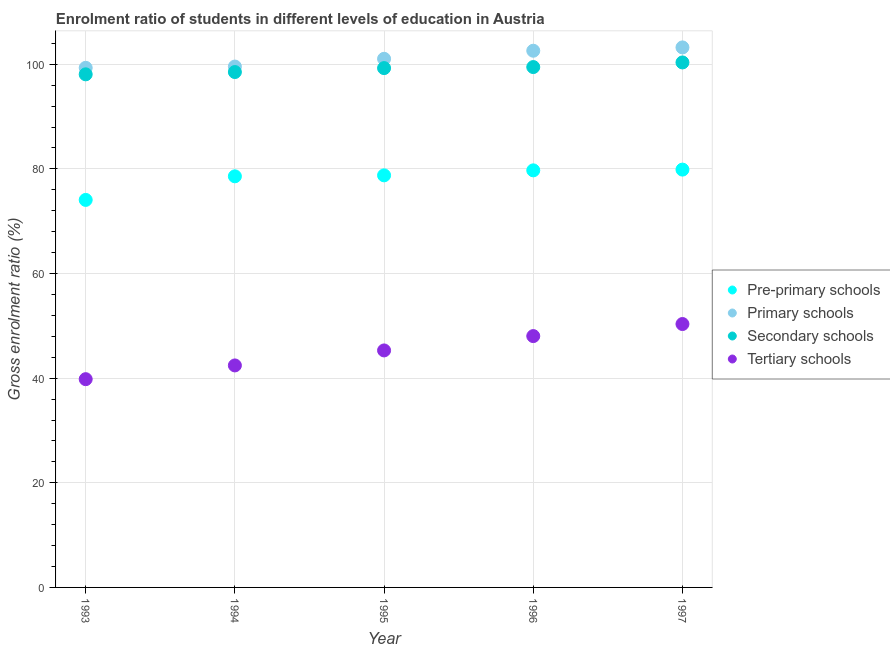Is the number of dotlines equal to the number of legend labels?
Your answer should be very brief. Yes. What is the gross enrolment ratio in primary schools in 1996?
Your answer should be very brief. 102.59. Across all years, what is the maximum gross enrolment ratio in pre-primary schools?
Offer a very short reply. 79.87. Across all years, what is the minimum gross enrolment ratio in primary schools?
Offer a terse response. 99.32. In which year was the gross enrolment ratio in primary schools maximum?
Your answer should be compact. 1997. In which year was the gross enrolment ratio in primary schools minimum?
Keep it short and to the point. 1993. What is the total gross enrolment ratio in tertiary schools in the graph?
Make the answer very short. 225.94. What is the difference between the gross enrolment ratio in pre-primary schools in 1994 and that in 1997?
Give a very brief answer. -1.28. What is the difference between the gross enrolment ratio in primary schools in 1993 and the gross enrolment ratio in pre-primary schools in 1996?
Keep it short and to the point. 19.6. What is the average gross enrolment ratio in pre-primary schools per year?
Your response must be concise. 78.2. In the year 1995, what is the difference between the gross enrolment ratio in pre-primary schools and gross enrolment ratio in tertiary schools?
Keep it short and to the point. 33.47. In how many years, is the gross enrolment ratio in secondary schools greater than 80 %?
Ensure brevity in your answer.  5. What is the ratio of the gross enrolment ratio in tertiary schools in 1993 to that in 1994?
Give a very brief answer. 0.94. What is the difference between the highest and the second highest gross enrolment ratio in primary schools?
Give a very brief answer. 0.63. What is the difference between the highest and the lowest gross enrolment ratio in secondary schools?
Your response must be concise. 2.27. In how many years, is the gross enrolment ratio in primary schools greater than the average gross enrolment ratio in primary schools taken over all years?
Your answer should be very brief. 2. Is it the case that in every year, the sum of the gross enrolment ratio in pre-primary schools and gross enrolment ratio in secondary schools is greater than the sum of gross enrolment ratio in tertiary schools and gross enrolment ratio in primary schools?
Your answer should be compact. Yes. Is it the case that in every year, the sum of the gross enrolment ratio in pre-primary schools and gross enrolment ratio in primary schools is greater than the gross enrolment ratio in secondary schools?
Offer a terse response. Yes. Does the gross enrolment ratio in tertiary schools monotonically increase over the years?
Provide a short and direct response. Yes. Is the gross enrolment ratio in secondary schools strictly less than the gross enrolment ratio in tertiary schools over the years?
Your answer should be very brief. No. Does the graph contain any zero values?
Give a very brief answer. No. What is the title of the graph?
Your response must be concise. Enrolment ratio of students in different levels of education in Austria. What is the label or title of the X-axis?
Provide a short and direct response. Year. What is the label or title of the Y-axis?
Your response must be concise. Gross enrolment ratio (%). What is the Gross enrolment ratio (%) in Pre-primary schools in 1993?
Your answer should be very brief. 74.07. What is the Gross enrolment ratio (%) of Primary schools in 1993?
Ensure brevity in your answer.  99.32. What is the Gross enrolment ratio (%) in Secondary schools in 1993?
Ensure brevity in your answer.  98.08. What is the Gross enrolment ratio (%) of Tertiary schools in 1993?
Keep it short and to the point. 39.81. What is the Gross enrolment ratio (%) of Pre-primary schools in 1994?
Keep it short and to the point. 78.59. What is the Gross enrolment ratio (%) in Primary schools in 1994?
Offer a terse response. 99.57. What is the Gross enrolment ratio (%) of Secondary schools in 1994?
Provide a short and direct response. 98.52. What is the Gross enrolment ratio (%) of Tertiary schools in 1994?
Provide a succinct answer. 42.43. What is the Gross enrolment ratio (%) of Pre-primary schools in 1995?
Keep it short and to the point. 78.77. What is the Gross enrolment ratio (%) of Primary schools in 1995?
Your answer should be compact. 101.05. What is the Gross enrolment ratio (%) of Secondary schools in 1995?
Your answer should be compact. 99.27. What is the Gross enrolment ratio (%) in Tertiary schools in 1995?
Your answer should be compact. 45.3. What is the Gross enrolment ratio (%) in Pre-primary schools in 1996?
Provide a short and direct response. 79.72. What is the Gross enrolment ratio (%) of Primary schools in 1996?
Your answer should be very brief. 102.59. What is the Gross enrolment ratio (%) of Secondary schools in 1996?
Offer a very short reply. 99.47. What is the Gross enrolment ratio (%) of Tertiary schools in 1996?
Ensure brevity in your answer.  48.04. What is the Gross enrolment ratio (%) of Pre-primary schools in 1997?
Your answer should be very brief. 79.87. What is the Gross enrolment ratio (%) of Primary schools in 1997?
Keep it short and to the point. 103.22. What is the Gross enrolment ratio (%) of Secondary schools in 1997?
Make the answer very short. 100.35. What is the Gross enrolment ratio (%) of Tertiary schools in 1997?
Offer a terse response. 50.35. Across all years, what is the maximum Gross enrolment ratio (%) in Pre-primary schools?
Your response must be concise. 79.87. Across all years, what is the maximum Gross enrolment ratio (%) of Primary schools?
Your response must be concise. 103.22. Across all years, what is the maximum Gross enrolment ratio (%) of Secondary schools?
Offer a very short reply. 100.35. Across all years, what is the maximum Gross enrolment ratio (%) in Tertiary schools?
Ensure brevity in your answer.  50.35. Across all years, what is the minimum Gross enrolment ratio (%) of Pre-primary schools?
Offer a very short reply. 74.07. Across all years, what is the minimum Gross enrolment ratio (%) of Primary schools?
Make the answer very short. 99.32. Across all years, what is the minimum Gross enrolment ratio (%) in Secondary schools?
Offer a terse response. 98.08. Across all years, what is the minimum Gross enrolment ratio (%) in Tertiary schools?
Give a very brief answer. 39.81. What is the total Gross enrolment ratio (%) of Pre-primary schools in the graph?
Provide a succinct answer. 391.02. What is the total Gross enrolment ratio (%) in Primary schools in the graph?
Give a very brief answer. 505.75. What is the total Gross enrolment ratio (%) in Secondary schools in the graph?
Provide a succinct answer. 495.68. What is the total Gross enrolment ratio (%) of Tertiary schools in the graph?
Provide a succinct answer. 225.94. What is the difference between the Gross enrolment ratio (%) in Pre-primary schools in 1993 and that in 1994?
Give a very brief answer. -4.51. What is the difference between the Gross enrolment ratio (%) in Primary schools in 1993 and that in 1994?
Offer a terse response. -0.24. What is the difference between the Gross enrolment ratio (%) of Secondary schools in 1993 and that in 1994?
Keep it short and to the point. -0.44. What is the difference between the Gross enrolment ratio (%) in Tertiary schools in 1993 and that in 1994?
Give a very brief answer. -2.63. What is the difference between the Gross enrolment ratio (%) in Pre-primary schools in 1993 and that in 1995?
Make the answer very short. -4.69. What is the difference between the Gross enrolment ratio (%) of Primary schools in 1993 and that in 1995?
Provide a succinct answer. -1.72. What is the difference between the Gross enrolment ratio (%) of Secondary schools in 1993 and that in 1995?
Provide a short and direct response. -1.19. What is the difference between the Gross enrolment ratio (%) in Tertiary schools in 1993 and that in 1995?
Provide a succinct answer. -5.49. What is the difference between the Gross enrolment ratio (%) of Pre-primary schools in 1993 and that in 1996?
Your response must be concise. -5.65. What is the difference between the Gross enrolment ratio (%) of Primary schools in 1993 and that in 1996?
Offer a very short reply. -3.27. What is the difference between the Gross enrolment ratio (%) of Secondary schools in 1993 and that in 1996?
Your answer should be very brief. -1.39. What is the difference between the Gross enrolment ratio (%) of Tertiary schools in 1993 and that in 1996?
Provide a short and direct response. -8.23. What is the difference between the Gross enrolment ratio (%) of Pre-primary schools in 1993 and that in 1997?
Provide a succinct answer. -5.79. What is the difference between the Gross enrolment ratio (%) in Primary schools in 1993 and that in 1997?
Make the answer very short. -3.9. What is the difference between the Gross enrolment ratio (%) in Secondary schools in 1993 and that in 1997?
Provide a short and direct response. -2.27. What is the difference between the Gross enrolment ratio (%) of Tertiary schools in 1993 and that in 1997?
Make the answer very short. -10.54. What is the difference between the Gross enrolment ratio (%) in Pre-primary schools in 1994 and that in 1995?
Give a very brief answer. -0.18. What is the difference between the Gross enrolment ratio (%) in Primary schools in 1994 and that in 1995?
Your response must be concise. -1.48. What is the difference between the Gross enrolment ratio (%) of Secondary schools in 1994 and that in 1995?
Give a very brief answer. -0.75. What is the difference between the Gross enrolment ratio (%) in Tertiary schools in 1994 and that in 1995?
Provide a succinct answer. -2.87. What is the difference between the Gross enrolment ratio (%) in Pre-primary schools in 1994 and that in 1996?
Keep it short and to the point. -1.14. What is the difference between the Gross enrolment ratio (%) in Primary schools in 1994 and that in 1996?
Make the answer very short. -3.02. What is the difference between the Gross enrolment ratio (%) of Secondary schools in 1994 and that in 1996?
Your answer should be very brief. -0.95. What is the difference between the Gross enrolment ratio (%) of Tertiary schools in 1994 and that in 1996?
Give a very brief answer. -5.61. What is the difference between the Gross enrolment ratio (%) in Pre-primary schools in 1994 and that in 1997?
Your answer should be very brief. -1.28. What is the difference between the Gross enrolment ratio (%) of Primary schools in 1994 and that in 1997?
Ensure brevity in your answer.  -3.66. What is the difference between the Gross enrolment ratio (%) in Secondary schools in 1994 and that in 1997?
Your answer should be very brief. -1.84. What is the difference between the Gross enrolment ratio (%) of Tertiary schools in 1994 and that in 1997?
Your answer should be compact. -7.91. What is the difference between the Gross enrolment ratio (%) of Pre-primary schools in 1995 and that in 1996?
Offer a terse response. -0.95. What is the difference between the Gross enrolment ratio (%) of Primary schools in 1995 and that in 1996?
Provide a succinct answer. -1.54. What is the difference between the Gross enrolment ratio (%) in Secondary schools in 1995 and that in 1996?
Provide a short and direct response. -0.2. What is the difference between the Gross enrolment ratio (%) in Tertiary schools in 1995 and that in 1996?
Your answer should be compact. -2.74. What is the difference between the Gross enrolment ratio (%) of Pre-primary schools in 1995 and that in 1997?
Your response must be concise. -1.1. What is the difference between the Gross enrolment ratio (%) of Primary schools in 1995 and that in 1997?
Your answer should be compact. -2.18. What is the difference between the Gross enrolment ratio (%) of Secondary schools in 1995 and that in 1997?
Keep it short and to the point. -1.08. What is the difference between the Gross enrolment ratio (%) in Tertiary schools in 1995 and that in 1997?
Your response must be concise. -5.05. What is the difference between the Gross enrolment ratio (%) of Pre-primary schools in 1996 and that in 1997?
Make the answer very short. -0.14. What is the difference between the Gross enrolment ratio (%) in Primary schools in 1996 and that in 1997?
Make the answer very short. -0.63. What is the difference between the Gross enrolment ratio (%) of Secondary schools in 1996 and that in 1997?
Make the answer very short. -0.88. What is the difference between the Gross enrolment ratio (%) in Tertiary schools in 1996 and that in 1997?
Offer a very short reply. -2.31. What is the difference between the Gross enrolment ratio (%) of Pre-primary schools in 1993 and the Gross enrolment ratio (%) of Primary schools in 1994?
Your response must be concise. -25.49. What is the difference between the Gross enrolment ratio (%) of Pre-primary schools in 1993 and the Gross enrolment ratio (%) of Secondary schools in 1994?
Offer a very short reply. -24.44. What is the difference between the Gross enrolment ratio (%) in Pre-primary schools in 1993 and the Gross enrolment ratio (%) in Tertiary schools in 1994?
Ensure brevity in your answer.  31.64. What is the difference between the Gross enrolment ratio (%) in Primary schools in 1993 and the Gross enrolment ratio (%) in Secondary schools in 1994?
Make the answer very short. 0.81. What is the difference between the Gross enrolment ratio (%) in Primary schools in 1993 and the Gross enrolment ratio (%) in Tertiary schools in 1994?
Provide a succinct answer. 56.89. What is the difference between the Gross enrolment ratio (%) in Secondary schools in 1993 and the Gross enrolment ratio (%) in Tertiary schools in 1994?
Make the answer very short. 55.64. What is the difference between the Gross enrolment ratio (%) in Pre-primary schools in 1993 and the Gross enrolment ratio (%) in Primary schools in 1995?
Make the answer very short. -26.97. What is the difference between the Gross enrolment ratio (%) of Pre-primary schools in 1993 and the Gross enrolment ratio (%) of Secondary schools in 1995?
Provide a short and direct response. -25.19. What is the difference between the Gross enrolment ratio (%) of Pre-primary schools in 1993 and the Gross enrolment ratio (%) of Tertiary schools in 1995?
Ensure brevity in your answer.  28.77. What is the difference between the Gross enrolment ratio (%) in Primary schools in 1993 and the Gross enrolment ratio (%) in Secondary schools in 1995?
Provide a short and direct response. 0.05. What is the difference between the Gross enrolment ratio (%) of Primary schools in 1993 and the Gross enrolment ratio (%) of Tertiary schools in 1995?
Provide a short and direct response. 54.02. What is the difference between the Gross enrolment ratio (%) of Secondary schools in 1993 and the Gross enrolment ratio (%) of Tertiary schools in 1995?
Keep it short and to the point. 52.78. What is the difference between the Gross enrolment ratio (%) of Pre-primary schools in 1993 and the Gross enrolment ratio (%) of Primary schools in 1996?
Keep it short and to the point. -28.52. What is the difference between the Gross enrolment ratio (%) in Pre-primary schools in 1993 and the Gross enrolment ratio (%) in Secondary schools in 1996?
Provide a succinct answer. -25.39. What is the difference between the Gross enrolment ratio (%) of Pre-primary schools in 1993 and the Gross enrolment ratio (%) of Tertiary schools in 1996?
Give a very brief answer. 26.03. What is the difference between the Gross enrolment ratio (%) of Primary schools in 1993 and the Gross enrolment ratio (%) of Secondary schools in 1996?
Provide a succinct answer. -0.15. What is the difference between the Gross enrolment ratio (%) in Primary schools in 1993 and the Gross enrolment ratio (%) in Tertiary schools in 1996?
Give a very brief answer. 51.28. What is the difference between the Gross enrolment ratio (%) in Secondary schools in 1993 and the Gross enrolment ratio (%) in Tertiary schools in 1996?
Ensure brevity in your answer.  50.04. What is the difference between the Gross enrolment ratio (%) in Pre-primary schools in 1993 and the Gross enrolment ratio (%) in Primary schools in 1997?
Provide a short and direct response. -29.15. What is the difference between the Gross enrolment ratio (%) in Pre-primary schools in 1993 and the Gross enrolment ratio (%) in Secondary schools in 1997?
Ensure brevity in your answer.  -26.28. What is the difference between the Gross enrolment ratio (%) in Pre-primary schools in 1993 and the Gross enrolment ratio (%) in Tertiary schools in 1997?
Offer a terse response. 23.72. What is the difference between the Gross enrolment ratio (%) in Primary schools in 1993 and the Gross enrolment ratio (%) in Secondary schools in 1997?
Your answer should be compact. -1.03. What is the difference between the Gross enrolment ratio (%) in Primary schools in 1993 and the Gross enrolment ratio (%) in Tertiary schools in 1997?
Offer a terse response. 48.97. What is the difference between the Gross enrolment ratio (%) in Secondary schools in 1993 and the Gross enrolment ratio (%) in Tertiary schools in 1997?
Provide a succinct answer. 47.73. What is the difference between the Gross enrolment ratio (%) of Pre-primary schools in 1994 and the Gross enrolment ratio (%) of Primary schools in 1995?
Make the answer very short. -22.46. What is the difference between the Gross enrolment ratio (%) in Pre-primary schools in 1994 and the Gross enrolment ratio (%) in Secondary schools in 1995?
Your answer should be very brief. -20.68. What is the difference between the Gross enrolment ratio (%) of Pre-primary schools in 1994 and the Gross enrolment ratio (%) of Tertiary schools in 1995?
Your answer should be compact. 33.28. What is the difference between the Gross enrolment ratio (%) in Primary schools in 1994 and the Gross enrolment ratio (%) in Secondary schools in 1995?
Offer a very short reply. 0.3. What is the difference between the Gross enrolment ratio (%) of Primary schools in 1994 and the Gross enrolment ratio (%) of Tertiary schools in 1995?
Provide a short and direct response. 54.26. What is the difference between the Gross enrolment ratio (%) in Secondary schools in 1994 and the Gross enrolment ratio (%) in Tertiary schools in 1995?
Your answer should be very brief. 53.21. What is the difference between the Gross enrolment ratio (%) in Pre-primary schools in 1994 and the Gross enrolment ratio (%) in Primary schools in 1996?
Make the answer very short. -24. What is the difference between the Gross enrolment ratio (%) in Pre-primary schools in 1994 and the Gross enrolment ratio (%) in Secondary schools in 1996?
Make the answer very short. -20.88. What is the difference between the Gross enrolment ratio (%) in Pre-primary schools in 1994 and the Gross enrolment ratio (%) in Tertiary schools in 1996?
Provide a succinct answer. 30.54. What is the difference between the Gross enrolment ratio (%) of Primary schools in 1994 and the Gross enrolment ratio (%) of Secondary schools in 1996?
Your answer should be very brief. 0.1. What is the difference between the Gross enrolment ratio (%) in Primary schools in 1994 and the Gross enrolment ratio (%) in Tertiary schools in 1996?
Offer a terse response. 51.52. What is the difference between the Gross enrolment ratio (%) in Secondary schools in 1994 and the Gross enrolment ratio (%) in Tertiary schools in 1996?
Your answer should be compact. 50.47. What is the difference between the Gross enrolment ratio (%) in Pre-primary schools in 1994 and the Gross enrolment ratio (%) in Primary schools in 1997?
Ensure brevity in your answer.  -24.64. What is the difference between the Gross enrolment ratio (%) in Pre-primary schools in 1994 and the Gross enrolment ratio (%) in Secondary schools in 1997?
Your response must be concise. -21.77. What is the difference between the Gross enrolment ratio (%) of Pre-primary schools in 1994 and the Gross enrolment ratio (%) of Tertiary schools in 1997?
Offer a terse response. 28.24. What is the difference between the Gross enrolment ratio (%) of Primary schools in 1994 and the Gross enrolment ratio (%) of Secondary schools in 1997?
Keep it short and to the point. -0.79. What is the difference between the Gross enrolment ratio (%) in Primary schools in 1994 and the Gross enrolment ratio (%) in Tertiary schools in 1997?
Make the answer very short. 49.22. What is the difference between the Gross enrolment ratio (%) of Secondary schools in 1994 and the Gross enrolment ratio (%) of Tertiary schools in 1997?
Keep it short and to the point. 48.17. What is the difference between the Gross enrolment ratio (%) in Pre-primary schools in 1995 and the Gross enrolment ratio (%) in Primary schools in 1996?
Your answer should be compact. -23.82. What is the difference between the Gross enrolment ratio (%) in Pre-primary schools in 1995 and the Gross enrolment ratio (%) in Secondary schools in 1996?
Offer a very short reply. -20.7. What is the difference between the Gross enrolment ratio (%) of Pre-primary schools in 1995 and the Gross enrolment ratio (%) of Tertiary schools in 1996?
Give a very brief answer. 30.73. What is the difference between the Gross enrolment ratio (%) of Primary schools in 1995 and the Gross enrolment ratio (%) of Secondary schools in 1996?
Give a very brief answer. 1.58. What is the difference between the Gross enrolment ratio (%) of Primary schools in 1995 and the Gross enrolment ratio (%) of Tertiary schools in 1996?
Provide a succinct answer. 53. What is the difference between the Gross enrolment ratio (%) of Secondary schools in 1995 and the Gross enrolment ratio (%) of Tertiary schools in 1996?
Provide a short and direct response. 51.23. What is the difference between the Gross enrolment ratio (%) in Pre-primary schools in 1995 and the Gross enrolment ratio (%) in Primary schools in 1997?
Provide a short and direct response. -24.46. What is the difference between the Gross enrolment ratio (%) in Pre-primary schools in 1995 and the Gross enrolment ratio (%) in Secondary schools in 1997?
Give a very brief answer. -21.58. What is the difference between the Gross enrolment ratio (%) of Pre-primary schools in 1995 and the Gross enrolment ratio (%) of Tertiary schools in 1997?
Keep it short and to the point. 28.42. What is the difference between the Gross enrolment ratio (%) in Primary schools in 1995 and the Gross enrolment ratio (%) in Secondary schools in 1997?
Your answer should be compact. 0.69. What is the difference between the Gross enrolment ratio (%) of Primary schools in 1995 and the Gross enrolment ratio (%) of Tertiary schools in 1997?
Your answer should be very brief. 50.7. What is the difference between the Gross enrolment ratio (%) in Secondary schools in 1995 and the Gross enrolment ratio (%) in Tertiary schools in 1997?
Give a very brief answer. 48.92. What is the difference between the Gross enrolment ratio (%) in Pre-primary schools in 1996 and the Gross enrolment ratio (%) in Primary schools in 1997?
Offer a terse response. -23.5. What is the difference between the Gross enrolment ratio (%) of Pre-primary schools in 1996 and the Gross enrolment ratio (%) of Secondary schools in 1997?
Your response must be concise. -20.63. What is the difference between the Gross enrolment ratio (%) in Pre-primary schools in 1996 and the Gross enrolment ratio (%) in Tertiary schools in 1997?
Your response must be concise. 29.37. What is the difference between the Gross enrolment ratio (%) of Primary schools in 1996 and the Gross enrolment ratio (%) of Secondary schools in 1997?
Your response must be concise. 2.24. What is the difference between the Gross enrolment ratio (%) of Primary schools in 1996 and the Gross enrolment ratio (%) of Tertiary schools in 1997?
Your answer should be compact. 52.24. What is the difference between the Gross enrolment ratio (%) in Secondary schools in 1996 and the Gross enrolment ratio (%) in Tertiary schools in 1997?
Provide a short and direct response. 49.12. What is the average Gross enrolment ratio (%) in Pre-primary schools per year?
Provide a short and direct response. 78.2. What is the average Gross enrolment ratio (%) in Primary schools per year?
Offer a terse response. 101.15. What is the average Gross enrolment ratio (%) of Secondary schools per year?
Ensure brevity in your answer.  99.14. What is the average Gross enrolment ratio (%) of Tertiary schools per year?
Provide a short and direct response. 45.19. In the year 1993, what is the difference between the Gross enrolment ratio (%) of Pre-primary schools and Gross enrolment ratio (%) of Primary schools?
Your response must be concise. -25.25. In the year 1993, what is the difference between the Gross enrolment ratio (%) in Pre-primary schools and Gross enrolment ratio (%) in Secondary schools?
Your answer should be compact. -24. In the year 1993, what is the difference between the Gross enrolment ratio (%) in Pre-primary schools and Gross enrolment ratio (%) in Tertiary schools?
Provide a short and direct response. 34.27. In the year 1993, what is the difference between the Gross enrolment ratio (%) in Primary schools and Gross enrolment ratio (%) in Secondary schools?
Provide a succinct answer. 1.24. In the year 1993, what is the difference between the Gross enrolment ratio (%) of Primary schools and Gross enrolment ratio (%) of Tertiary schools?
Give a very brief answer. 59.51. In the year 1993, what is the difference between the Gross enrolment ratio (%) in Secondary schools and Gross enrolment ratio (%) in Tertiary schools?
Keep it short and to the point. 58.27. In the year 1994, what is the difference between the Gross enrolment ratio (%) of Pre-primary schools and Gross enrolment ratio (%) of Primary schools?
Offer a very short reply. -20.98. In the year 1994, what is the difference between the Gross enrolment ratio (%) of Pre-primary schools and Gross enrolment ratio (%) of Secondary schools?
Your response must be concise. -19.93. In the year 1994, what is the difference between the Gross enrolment ratio (%) in Pre-primary schools and Gross enrolment ratio (%) in Tertiary schools?
Offer a terse response. 36.15. In the year 1994, what is the difference between the Gross enrolment ratio (%) in Primary schools and Gross enrolment ratio (%) in Secondary schools?
Make the answer very short. 1.05. In the year 1994, what is the difference between the Gross enrolment ratio (%) in Primary schools and Gross enrolment ratio (%) in Tertiary schools?
Provide a short and direct response. 57.13. In the year 1994, what is the difference between the Gross enrolment ratio (%) of Secondary schools and Gross enrolment ratio (%) of Tertiary schools?
Offer a terse response. 56.08. In the year 1995, what is the difference between the Gross enrolment ratio (%) in Pre-primary schools and Gross enrolment ratio (%) in Primary schools?
Keep it short and to the point. -22.28. In the year 1995, what is the difference between the Gross enrolment ratio (%) in Pre-primary schools and Gross enrolment ratio (%) in Secondary schools?
Offer a very short reply. -20.5. In the year 1995, what is the difference between the Gross enrolment ratio (%) of Pre-primary schools and Gross enrolment ratio (%) of Tertiary schools?
Keep it short and to the point. 33.47. In the year 1995, what is the difference between the Gross enrolment ratio (%) of Primary schools and Gross enrolment ratio (%) of Secondary schools?
Keep it short and to the point. 1.78. In the year 1995, what is the difference between the Gross enrolment ratio (%) in Primary schools and Gross enrolment ratio (%) in Tertiary schools?
Your answer should be very brief. 55.74. In the year 1995, what is the difference between the Gross enrolment ratio (%) of Secondary schools and Gross enrolment ratio (%) of Tertiary schools?
Your answer should be very brief. 53.97. In the year 1996, what is the difference between the Gross enrolment ratio (%) of Pre-primary schools and Gross enrolment ratio (%) of Primary schools?
Your answer should be compact. -22.87. In the year 1996, what is the difference between the Gross enrolment ratio (%) of Pre-primary schools and Gross enrolment ratio (%) of Secondary schools?
Offer a very short reply. -19.74. In the year 1996, what is the difference between the Gross enrolment ratio (%) in Pre-primary schools and Gross enrolment ratio (%) in Tertiary schools?
Provide a succinct answer. 31.68. In the year 1996, what is the difference between the Gross enrolment ratio (%) in Primary schools and Gross enrolment ratio (%) in Secondary schools?
Give a very brief answer. 3.12. In the year 1996, what is the difference between the Gross enrolment ratio (%) of Primary schools and Gross enrolment ratio (%) of Tertiary schools?
Your answer should be compact. 54.55. In the year 1996, what is the difference between the Gross enrolment ratio (%) of Secondary schools and Gross enrolment ratio (%) of Tertiary schools?
Ensure brevity in your answer.  51.43. In the year 1997, what is the difference between the Gross enrolment ratio (%) of Pre-primary schools and Gross enrolment ratio (%) of Primary schools?
Keep it short and to the point. -23.36. In the year 1997, what is the difference between the Gross enrolment ratio (%) in Pre-primary schools and Gross enrolment ratio (%) in Secondary schools?
Offer a very short reply. -20.49. In the year 1997, what is the difference between the Gross enrolment ratio (%) in Pre-primary schools and Gross enrolment ratio (%) in Tertiary schools?
Make the answer very short. 29.52. In the year 1997, what is the difference between the Gross enrolment ratio (%) of Primary schools and Gross enrolment ratio (%) of Secondary schools?
Offer a very short reply. 2.87. In the year 1997, what is the difference between the Gross enrolment ratio (%) of Primary schools and Gross enrolment ratio (%) of Tertiary schools?
Offer a very short reply. 52.88. In the year 1997, what is the difference between the Gross enrolment ratio (%) in Secondary schools and Gross enrolment ratio (%) in Tertiary schools?
Provide a short and direct response. 50. What is the ratio of the Gross enrolment ratio (%) in Pre-primary schools in 1993 to that in 1994?
Your answer should be compact. 0.94. What is the ratio of the Gross enrolment ratio (%) of Secondary schools in 1993 to that in 1994?
Make the answer very short. 1. What is the ratio of the Gross enrolment ratio (%) in Tertiary schools in 1993 to that in 1994?
Ensure brevity in your answer.  0.94. What is the ratio of the Gross enrolment ratio (%) of Pre-primary schools in 1993 to that in 1995?
Your answer should be compact. 0.94. What is the ratio of the Gross enrolment ratio (%) in Primary schools in 1993 to that in 1995?
Make the answer very short. 0.98. What is the ratio of the Gross enrolment ratio (%) of Secondary schools in 1993 to that in 1995?
Provide a short and direct response. 0.99. What is the ratio of the Gross enrolment ratio (%) in Tertiary schools in 1993 to that in 1995?
Ensure brevity in your answer.  0.88. What is the ratio of the Gross enrolment ratio (%) in Pre-primary schools in 1993 to that in 1996?
Your answer should be compact. 0.93. What is the ratio of the Gross enrolment ratio (%) in Primary schools in 1993 to that in 1996?
Offer a terse response. 0.97. What is the ratio of the Gross enrolment ratio (%) of Tertiary schools in 1993 to that in 1996?
Make the answer very short. 0.83. What is the ratio of the Gross enrolment ratio (%) in Pre-primary schools in 1993 to that in 1997?
Your response must be concise. 0.93. What is the ratio of the Gross enrolment ratio (%) of Primary schools in 1993 to that in 1997?
Ensure brevity in your answer.  0.96. What is the ratio of the Gross enrolment ratio (%) of Secondary schools in 1993 to that in 1997?
Keep it short and to the point. 0.98. What is the ratio of the Gross enrolment ratio (%) in Tertiary schools in 1993 to that in 1997?
Ensure brevity in your answer.  0.79. What is the ratio of the Gross enrolment ratio (%) of Pre-primary schools in 1994 to that in 1995?
Offer a very short reply. 1. What is the ratio of the Gross enrolment ratio (%) of Primary schools in 1994 to that in 1995?
Give a very brief answer. 0.99. What is the ratio of the Gross enrolment ratio (%) in Secondary schools in 1994 to that in 1995?
Provide a succinct answer. 0.99. What is the ratio of the Gross enrolment ratio (%) of Tertiary schools in 1994 to that in 1995?
Provide a short and direct response. 0.94. What is the ratio of the Gross enrolment ratio (%) of Pre-primary schools in 1994 to that in 1996?
Provide a succinct answer. 0.99. What is the ratio of the Gross enrolment ratio (%) of Primary schools in 1994 to that in 1996?
Make the answer very short. 0.97. What is the ratio of the Gross enrolment ratio (%) in Secondary schools in 1994 to that in 1996?
Give a very brief answer. 0.99. What is the ratio of the Gross enrolment ratio (%) in Tertiary schools in 1994 to that in 1996?
Keep it short and to the point. 0.88. What is the ratio of the Gross enrolment ratio (%) of Pre-primary schools in 1994 to that in 1997?
Provide a succinct answer. 0.98. What is the ratio of the Gross enrolment ratio (%) in Primary schools in 1994 to that in 1997?
Offer a terse response. 0.96. What is the ratio of the Gross enrolment ratio (%) of Secondary schools in 1994 to that in 1997?
Give a very brief answer. 0.98. What is the ratio of the Gross enrolment ratio (%) of Tertiary schools in 1994 to that in 1997?
Offer a terse response. 0.84. What is the ratio of the Gross enrolment ratio (%) in Pre-primary schools in 1995 to that in 1996?
Your answer should be very brief. 0.99. What is the ratio of the Gross enrolment ratio (%) in Tertiary schools in 1995 to that in 1996?
Offer a very short reply. 0.94. What is the ratio of the Gross enrolment ratio (%) in Pre-primary schools in 1995 to that in 1997?
Offer a terse response. 0.99. What is the ratio of the Gross enrolment ratio (%) in Primary schools in 1995 to that in 1997?
Your response must be concise. 0.98. What is the ratio of the Gross enrolment ratio (%) in Secondary schools in 1995 to that in 1997?
Your answer should be very brief. 0.99. What is the ratio of the Gross enrolment ratio (%) in Tertiary schools in 1995 to that in 1997?
Provide a short and direct response. 0.9. What is the ratio of the Gross enrolment ratio (%) of Pre-primary schools in 1996 to that in 1997?
Keep it short and to the point. 1. What is the ratio of the Gross enrolment ratio (%) of Primary schools in 1996 to that in 1997?
Your response must be concise. 0.99. What is the ratio of the Gross enrolment ratio (%) in Secondary schools in 1996 to that in 1997?
Your answer should be compact. 0.99. What is the ratio of the Gross enrolment ratio (%) in Tertiary schools in 1996 to that in 1997?
Keep it short and to the point. 0.95. What is the difference between the highest and the second highest Gross enrolment ratio (%) of Pre-primary schools?
Make the answer very short. 0.14. What is the difference between the highest and the second highest Gross enrolment ratio (%) in Primary schools?
Offer a terse response. 0.63. What is the difference between the highest and the second highest Gross enrolment ratio (%) of Secondary schools?
Your response must be concise. 0.88. What is the difference between the highest and the second highest Gross enrolment ratio (%) of Tertiary schools?
Provide a succinct answer. 2.31. What is the difference between the highest and the lowest Gross enrolment ratio (%) in Pre-primary schools?
Make the answer very short. 5.79. What is the difference between the highest and the lowest Gross enrolment ratio (%) of Primary schools?
Make the answer very short. 3.9. What is the difference between the highest and the lowest Gross enrolment ratio (%) of Secondary schools?
Provide a short and direct response. 2.27. What is the difference between the highest and the lowest Gross enrolment ratio (%) in Tertiary schools?
Give a very brief answer. 10.54. 